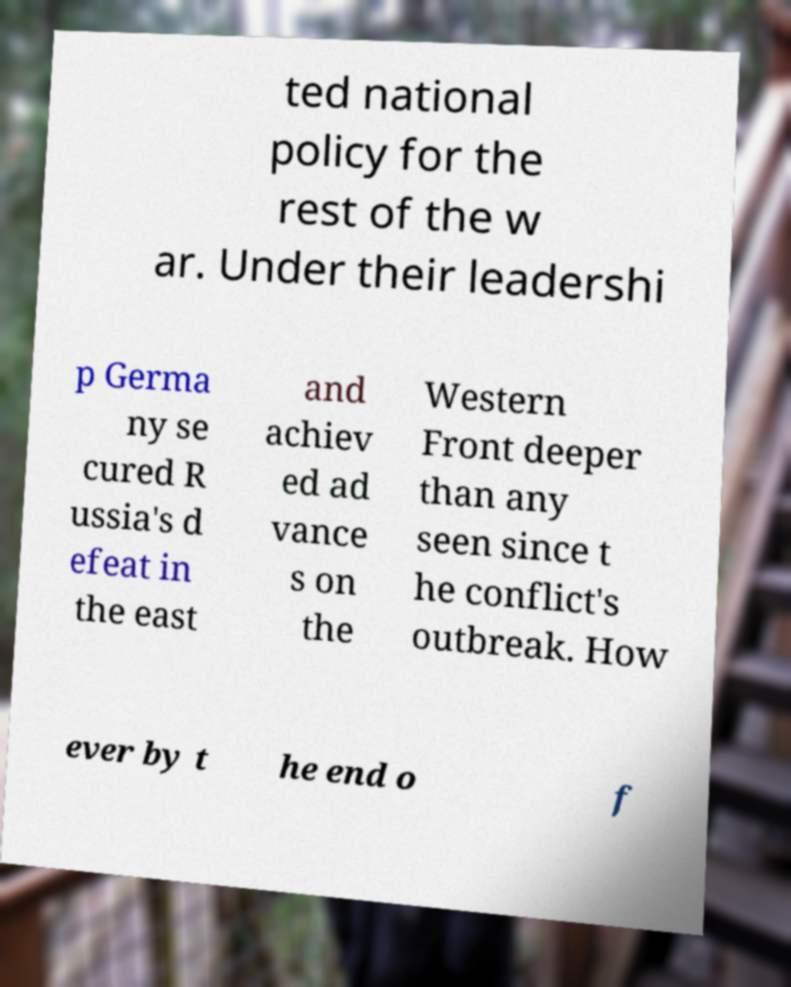Please identify and transcribe the text found in this image. ted national policy for the rest of the w ar. Under their leadershi p Germa ny se cured R ussia's d efeat in the east and achiev ed ad vance s on the Western Front deeper than any seen since t he conflict's outbreak. How ever by t he end o f 